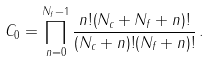<formula> <loc_0><loc_0><loc_500><loc_500>C _ { 0 } = \prod _ { n = 0 } ^ { N _ { f } - 1 } \frac { n ! ( N _ { c } + N _ { f } + n ) ! } { ( N _ { c } + n ) ! ( N _ { f } + n ) ! } \, .</formula> 